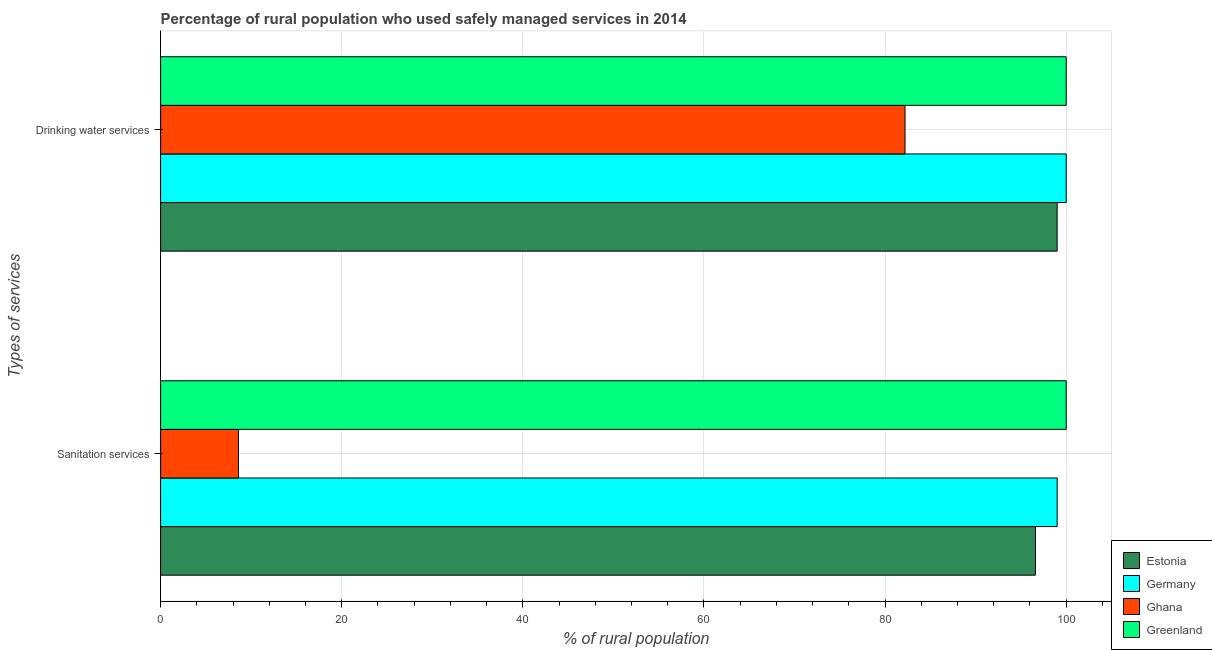What is the label of the 1st group of bars from the top?
Make the answer very short. Drinking water services. What is the percentage of rural population who used sanitation services in Estonia?
Keep it short and to the point. 96.6. Across all countries, what is the maximum percentage of rural population who used drinking water services?
Offer a very short reply. 100. In which country was the percentage of rural population who used sanitation services maximum?
Make the answer very short. Greenland. In which country was the percentage of rural population who used sanitation services minimum?
Your response must be concise. Ghana. What is the total percentage of rural population who used drinking water services in the graph?
Make the answer very short. 381.2. What is the difference between the percentage of rural population who used sanitation services in Ghana and that in Estonia?
Provide a short and direct response. -88. What is the average percentage of rural population who used drinking water services per country?
Offer a very short reply. 95.3. What is the difference between the percentage of rural population who used drinking water services and percentage of rural population who used sanitation services in Estonia?
Ensure brevity in your answer.  2.4. In how many countries, is the percentage of rural population who used drinking water services greater than 96 %?
Keep it short and to the point. 3. What is the ratio of the percentage of rural population who used sanitation services in Ghana to that in Greenland?
Make the answer very short. 0.09. Is the percentage of rural population who used drinking water services in Ghana less than that in Germany?
Offer a very short reply. Yes. In how many countries, is the percentage of rural population who used drinking water services greater than the average percentage of rural population who used drinking water services taken over all countries?
Keep it short and to the point. 3. What does the 4th bar from the top in Sanitation services represents?
Make the answer very short. Estonia. What does the 3rd bar from the bottom in Drinking water services represents?
Your answer should be very brief. Ghana. How many bars are there?
Your response must be concise. 8. Are all the bars in the graph horizontal?
Give a very brief answer. Yes. How many countries are there in the graph?
Offer a terse response. 4. Where does the legend appear in the graph?
Provide a succinct answer. Bottom right. What is the title of the graph?
Make the answer very short. Percentage of rural population who used safely managed services in 2014. Does "World" appear as one of the legend labels in the graph?
Keep it short and to the point. No. What is the label or title of the X-axis?
Give a very brief answer. % of rural population. What is the label or title of the Y-axis?
Keep it short and to the point. Types of services. What is the % of rural population in Estonia in Sanitation services?
Your answer should be compact. 96.6. What is the % of rural population in Ghana in Drinking water services?
Give a very brief answer. 82.2. Across all Types of services, what is the maximum % of rural population in Ghana?
Offer a terse response. 82.2. Across all Types of services, what is the minimum % of rural population in Estonia?
Make the answer very short. 96.6. Across all Types of services, what is the minimum % of rural population of Ghana?
Your answer should be very brief. 8.6. What is the total % of rural population in Estonia in the graph?
Offer a very short reply. 195.6. What is the total % of rural population in Germany in the graph?
Your answer should be compact. 199. What is the total % of rural population of Ghana in the graph?
Your answer should be very brief. 90.8. What is the total % of rural population of Greenland in the graph?
Your answer should be compact. 200. What is the difference between the % of rural population of Estonia in Sanitation services and that in Drinking water services?
Your answer should be very brief. -2.4. What is the difference between the % of rural population of Ghana in Sanitation services and that in Drinking water services?
Provide a succinct answer. -73.6. What is the difference between the % of rural population in Greenland in Sanitation services and that in Drinking water services?
Offer a very short reply. 0. What is the difference between the % of rural population in Estonia in Sanitation services and the % of rural population in Germany in Drinking water services?
Provide a succinct answer. -3.4. What is the difference between the % of rural population of Estonia in Sanitation services and the % of rural population of Ghana in Drinking water services?
Your answer should be very brief. 14.4. What is the difference between the % of rural population of Estonia in Sanitation services and the % of rural population of Greenland in Drinking water services?
Your answer should be very brief. -3.4. What is the difference between the % of rural population of Germany in Sanitation services and the % of rural population of Greenland in Drinking water services?
Your answer should be compact. -1. What is the difference between the % of rural population in Ghana in Sanitation services and the % of rural population in Greenland in Drinking water services?
Keep it short and to the point. -91.4. What is the average % of rural population of Estonia per Types of services?
Your answer should be very brief. 97.8. What is the average % of rural population of Germany per Types of services?
Keep it short and to the point. 99.5. What is the average % of rural population of Ghana per Types of services?
Provide a succinct answer. 45.4. What is the difference between the % of rural population of Estonia and % of rural population of Greenland in Sanitation services?
Your response must be concise. -3.4. What is the difference between the % of rural population of Germany and % of rural population of Ghana in Sanitation services?
Make the answer very short. 90.4. What is the difference between the % of rural population of Germany and % of rural population of Greenland in Sanitation services?
Give a very brief answer. -1. What is the difference between the % of rural population of Ghana and % of rural population of Greenland in Sanitation services?
Provide a short and direct response. -91.4. What is the difference between the % of rural population of Estonia and % of rural population of Greenland in Drinking water services?
Make the answer very short. -1. What is the difference between the % of rural population of Germany and % of rural population of Ghana in Drinking water services?
Your response must be concise. 17.8. What is the difference between the % of rural population in Germany and % of rural population in Greenland in Drinking water services?
Your answer should be compact. 0. What is the difference between the % of rural population of Ghana and % of rural population of Greenland in Drinking water services?
Provide a succinct answer. -17.8. What is the ratio of the % of rural population in Estonia in Sanitation services to that in Drinking water services?
Your answer should be compact. 0.98. What is the ratio of the % of rural population in Germany in Sanitation services to that in Drinking water services?
Offer a very short reply. 0.99. What is the ratio of the % of rural population of Ghana in Sanitation services to that in Drinking water services?
Provide a succinct answer. 0.1. What is the ratio of the % of rural population of Greenland in Sanitation services to that in Drinking water services?
Give a very brief answer. 1. What is the difference between the highest and the second highest % of rural population of Estonia?
Give a very brief answer. 2.4. What is the difference between the highest and the second highest % of rural population of Ghana?
Give a very brief answer. 73.6. What is the difference between the highest and the lowest % of rural population of Estonia?
Keep it short and to the point. 2.4. What is the difference between the highest and the lowest % of rural population in Ghana?
Offer a very short reply. 73.6. 